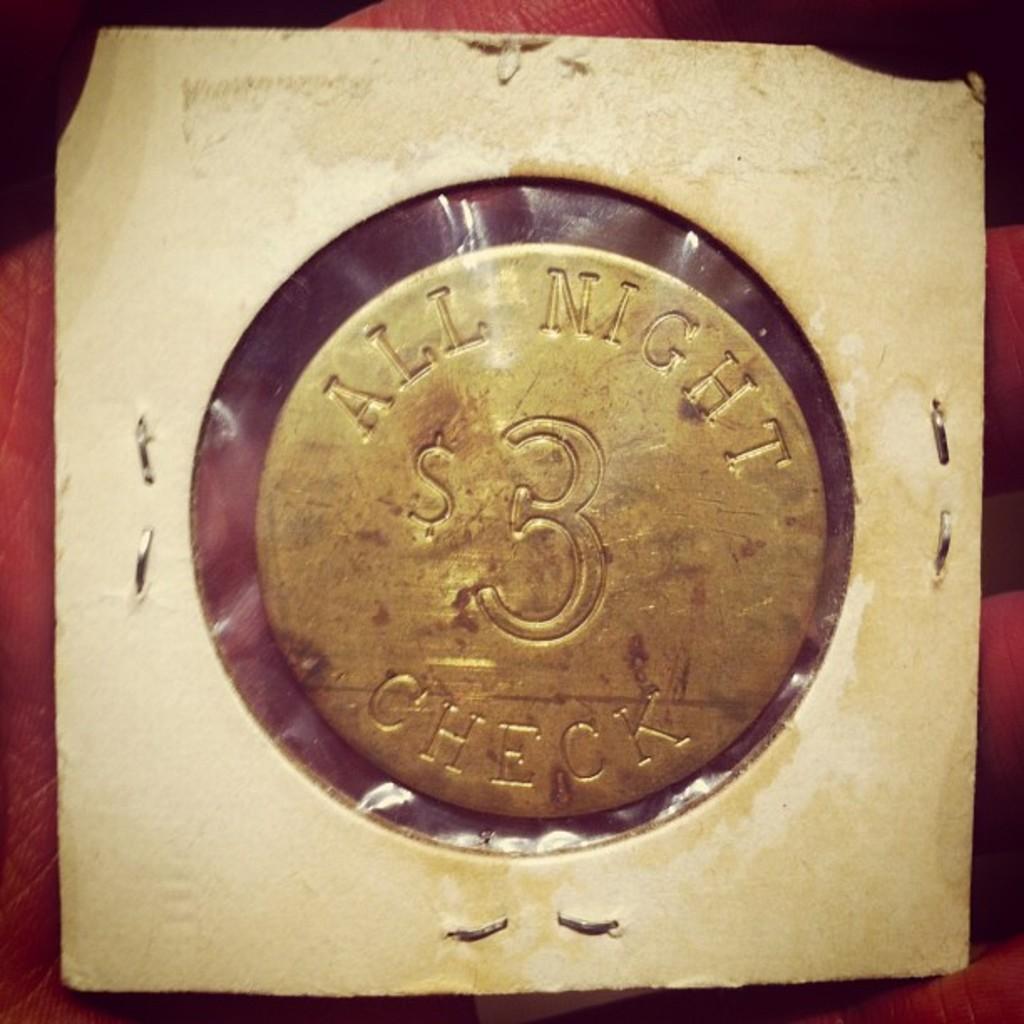How much is the all night check?
Keep it short and to the point. $3. 